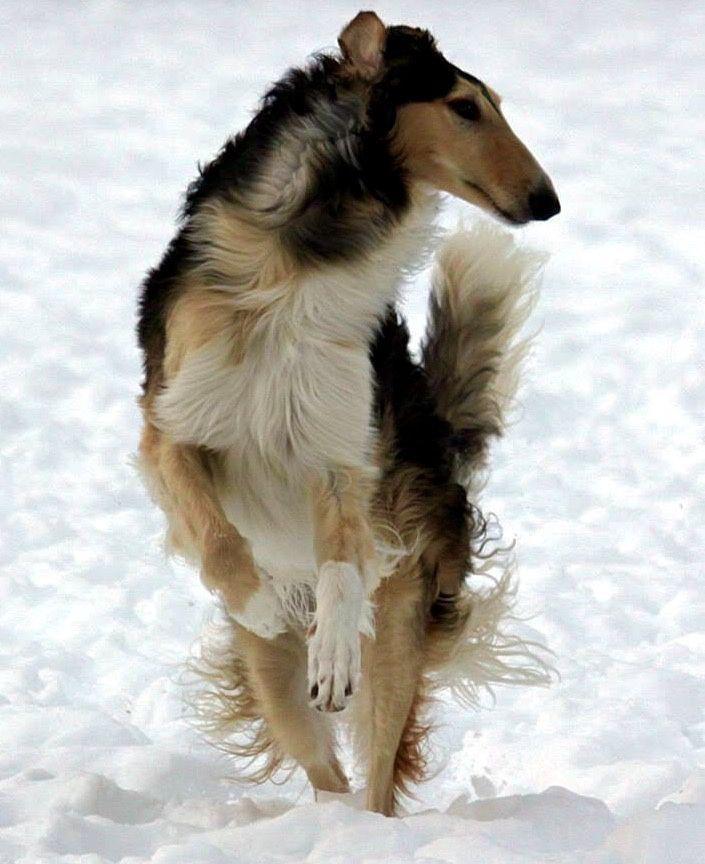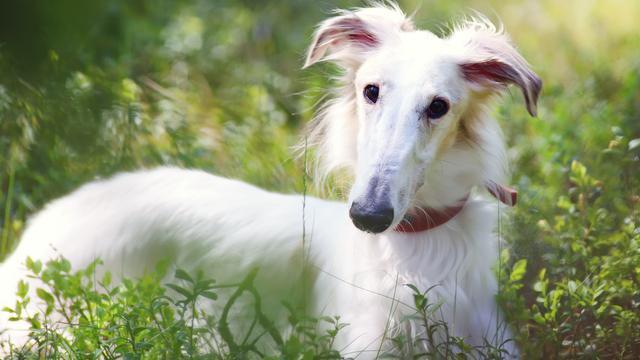The first image is the image on the left, the second image is the image on the right. Considering the images on both sides, is "A dog is standing in a field in the image on the right." valid? Answer yes or no. No. The first image is the image on the left, the second image is the image on the right. Examine the images to the left and right. Is the description "The dog in the left image is standing on the sidewalk." accurate? Answer yes or no. No. 